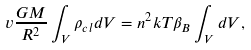Convert formula to latex. <formula><loc_0><loc_0><loc_500><loc_500>v \frac { G M } { R ^ { 2 } } \int _ { V } { \rho } _ { c l } d V = n ^ { 2 } k T \beta _ { B } \int _ { V } d V ,</formula> 